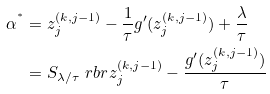<formula> <loc_0><loc_0><loc_500><loc_500>\alpha ^ { ^ { * } } & = z ^ { ( k , j - 1 ) } _ { j } - \frac { 1 } { \tau } g ^ { \prime } ( z ^ { ( k , j - 1 ) } _ { j } ) + \frac { \lambda } { \tau } \\ & = S _ { \lambda / \tau } \ r b r { z ^ { ( k , j - 1 ) } _ { j } - \frac { g ^ { \prime } ( z ^ { ( k , j - 1 ) } _ { j } ) } { \tau } }</formula> 